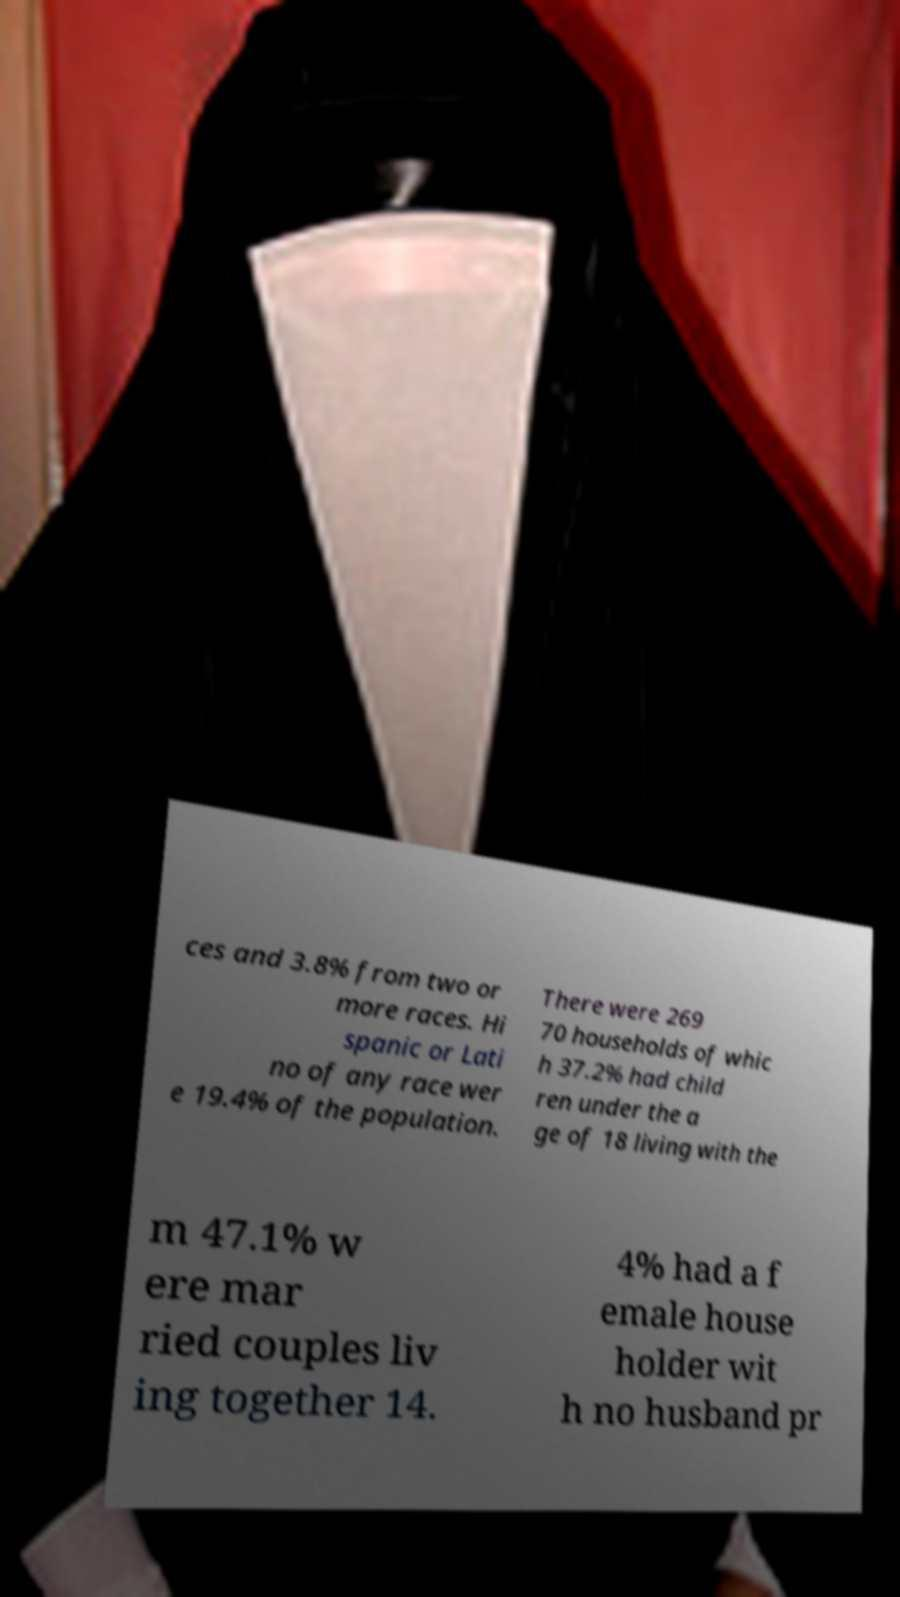What messages or text are displayed in this image? I need them in a readable, typed format. ces and 3.8% from two or more races. Hi spanic or Lati no of any race wer e 19.4% of the population. There were 269 70 households of whic h 37.2% had child ren under the a ge of 18 living with the m 47.1% w ere mar ried couples liv ing together 14. 4% had a f emale house holder wit h no husband pr 